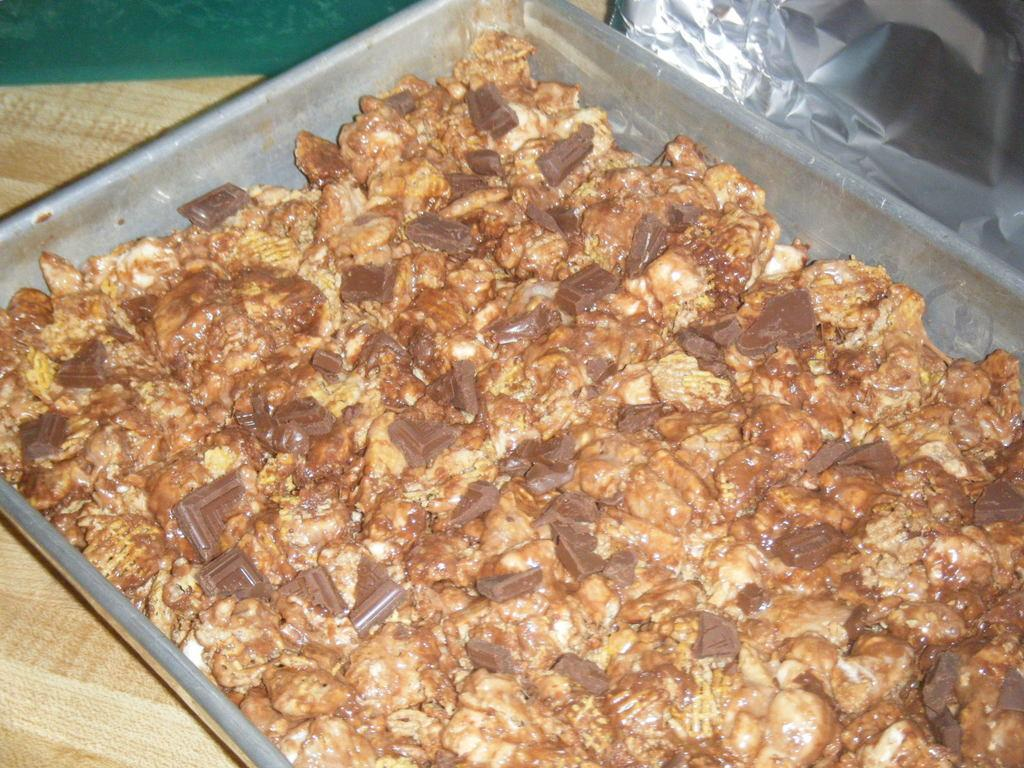What type of tray is visible in the image? There is a steel tray in the image. What is on the steel tray? The steel tray contains food. On what surface is the steel tray placed? The steel tray is placed on a wooden surface. Is there any covering on the food in the image? Yes, there is a foil cover in the image. How many pigs are visible in the image? There are no pigs present in the image. What finger is used to lift the foil cover in the image? The image does not show any fingers lifting the foil cover, nor is there any indication of who might be doing so. 